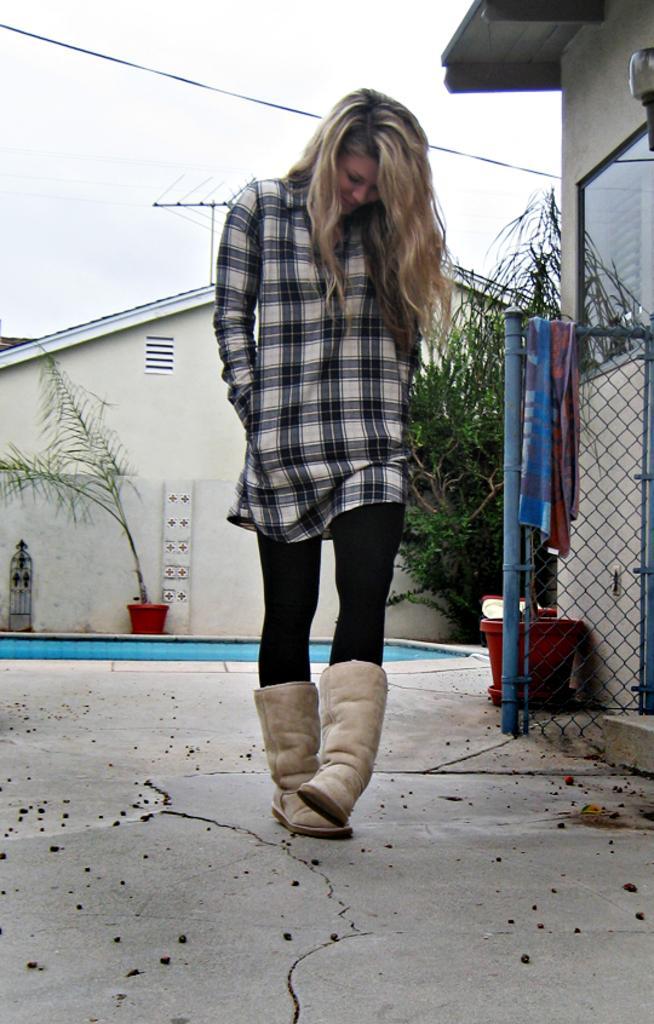In one or two sentences, can you explain what this image depicts? In this picture there is a woman walking. At the back there are buildings. On the right side of the image there is a cloth on the fence and there are plants in the pots. There is an object on the wall. At the top there is sky and there are wires. At the bottom there is a floor. 